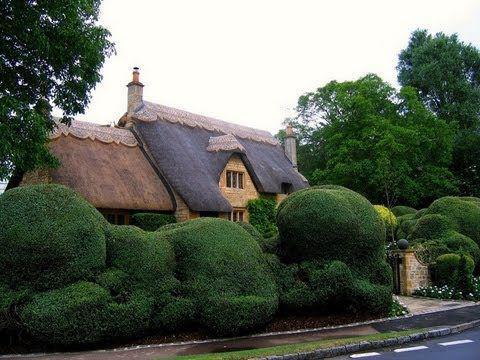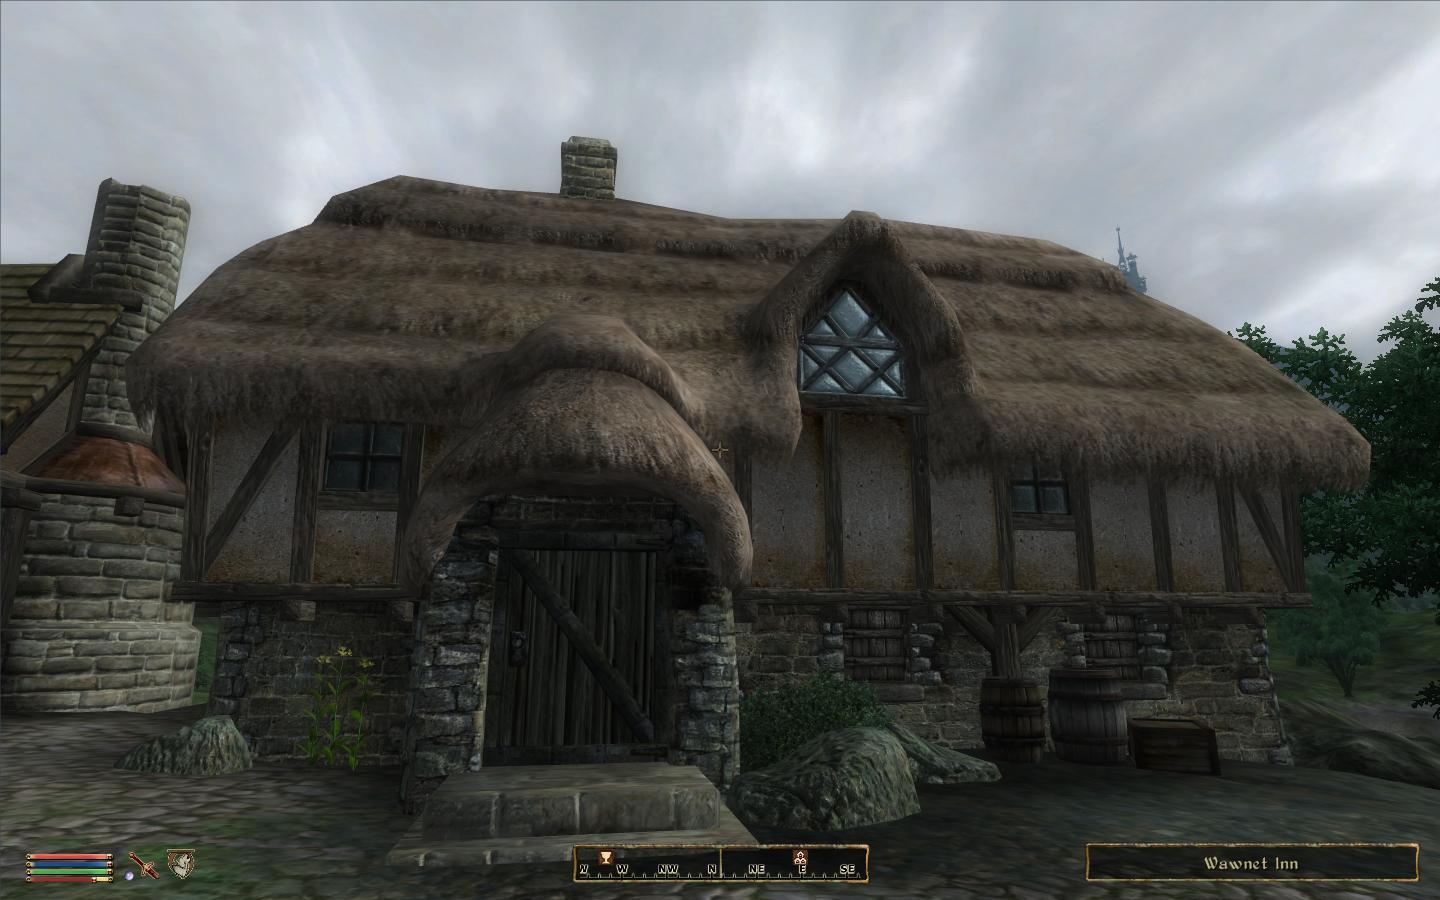The first image is the image on the left, the second image is the image on the right. Considering the images on both sides, is "In at least one image there are at least four oversized green bushes blocking the front of a home with at least two chimneys" valid? Answer yes or no. Yes. The first image is the image on the left, the second image is the image on the right. Examine the images to the left and right. Is the description "The left image features a house with multiple chimneys atop a dark gray roof with a scalloped border on top, and curving asymmetrical hedges in front." accurate? Answer yes or no. Yes. 